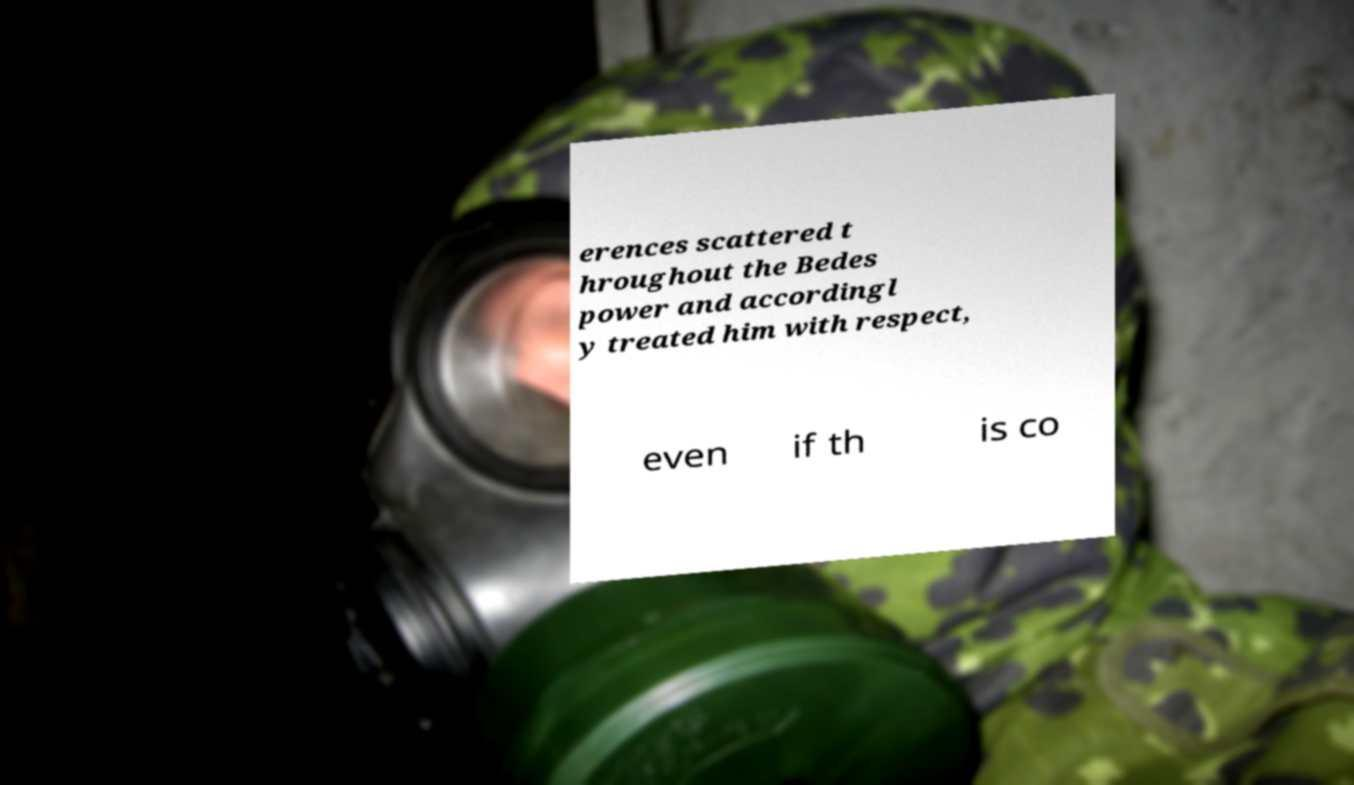Could you assist in decoding the text presented in this image and type it out clearly? erences scattered t hroughout the Bedes power and accordingl y treated him with respect, even if th is co 